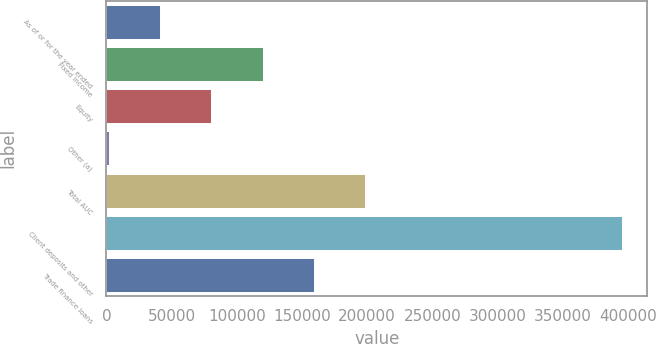Convert chart to OTSL. <chart><loc_0><loc_0><loc_500><loc_500><bar_chart><fcel>As of or for the year ended<fcel>Fixed Income<fcel>Equity<fcel>Other (a)<fcel>Total AUC<fcel>Client deposits and other<fcel>Trade finance loans<nl><fcel>41066<fcel>119784<fcel>80425<fcel>1707<fcel>198502<fcel>395297<fcel>159143<nl></chart> 